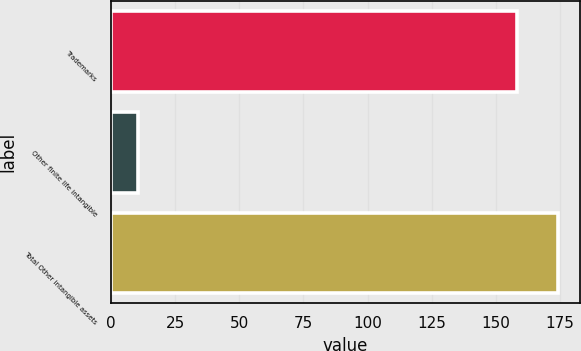Convert chart to OTSL. <chart><loc_0><loc_0><loc_500><loc_500><bar_chart><fcel>Trademarks<fcel>Other finite life intangible<fcel>Total Other intangible assets<nl><fcel>158.2<fcel>10.6<fcel>174.02<nl></chart> 